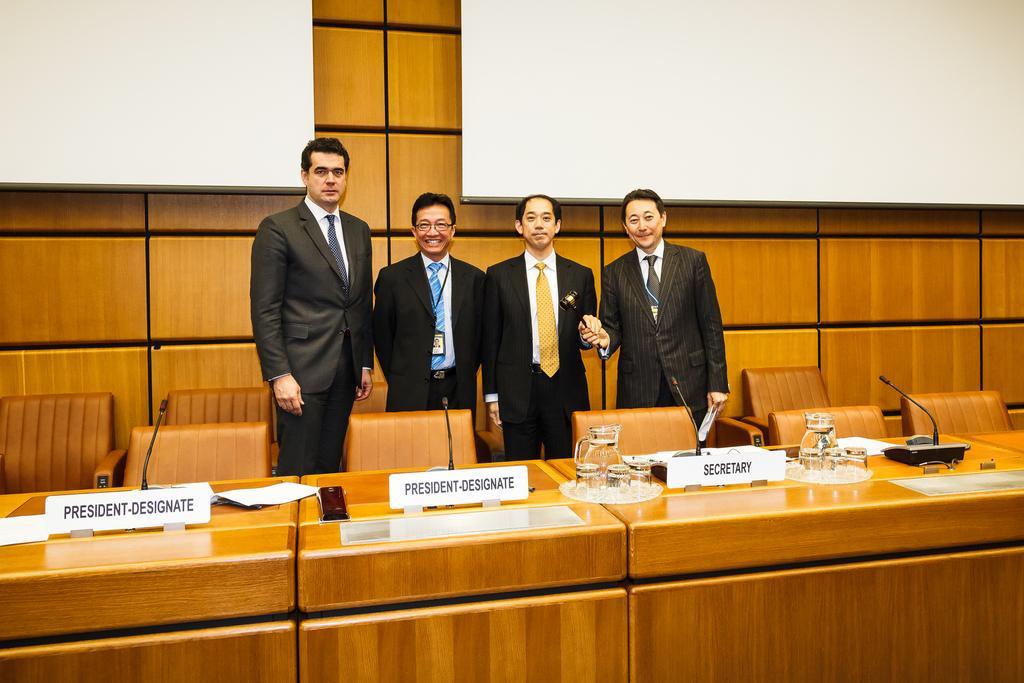How would you summarize this image in a sentence or two? In this image we can see four men standing on the floor. They are wearing a suit and a tie. Here we can see two smiling men. Here we can see the wooden tables and chairs. Here we can see a water jar, glasses, name plate boards, papers and microphones are kept on the table. 